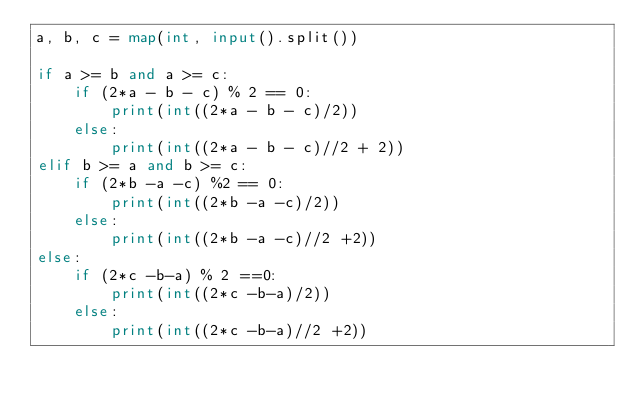<code> <loc_0><loc_0><loc_500><loc_500><_Python_>a, b, c = map(int, input().split())

if a >= b and a >= c:
    if (2*a - b - c) % 2 == 0:
        print(int((2*a - b - c)/2))
    else:
        print(int((2*a - b - c)//2 + 2))
elif b >= a and b >= c:
    if (2*b -a -c) %2 == 0:
        print(int((2*b -a -c)/2))
    else:
        print(int((2*b -a -c)//2 +2))
else:
    if (2*c -b-a) % 2 ==0:
        print(int((2*c -b-a)/2))
    else:
        print(int((2*c -b-a)//2 +2))
</code> 